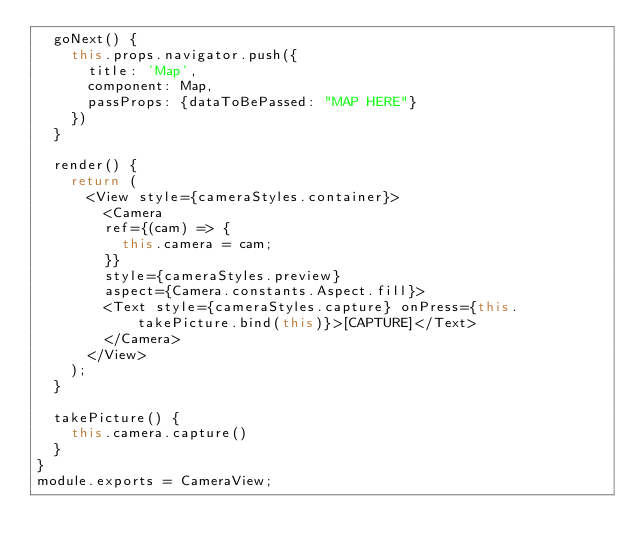Convert code to text. <code><loc_0><loc_0><loc_500><loc_500><_JavaScript_>  goNext() {
    this.props.navigator.push({
      title: 'Map',
      component: Map,
      passProps: {dataToBePassed: "MAP HERE"}
    })
  }

  render() {
    return (
      <View style={cameraStyles.container}>
        <Camera
        ref={(cam) => {
          this.camera = cam;
        }}
        style={cameraStyles.preview}
        aspect={Camera.constants.Aspect.fill}>
        <Text style={cameraStyles.capture} onPress={this.takePicture.bind(this)}>[CAPTURE]</Text>
        </Camera>
      </View>
    );
  }

  takePicture() {
    this.camera.capture()
  }
}
module.exports = CameraView;
</code> 